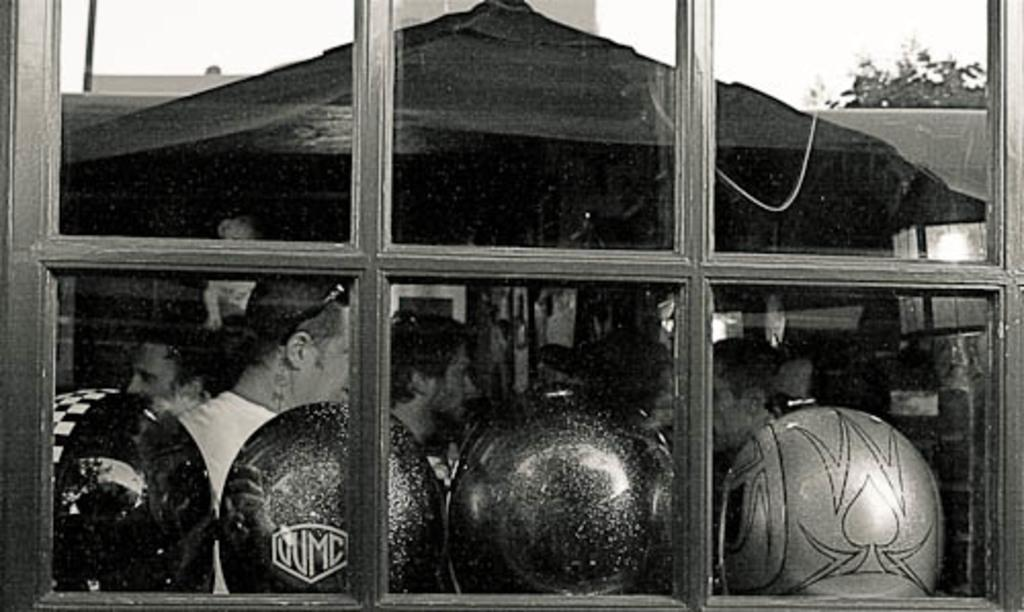What are the people in the image doing? The people in the image are standing under a tent. What protective gear can be seen in the image? There are helmets visible in the image. What type of structures are present in the image? There are buildings in the image. What natural elements can be seen in the image? Tree branches are present in the top right corner of the image. What type of furniture is present in the image? There is no furniture present in the image. What emotion are the people in the image experiencing? The image does not provide any information about the emotions of the people in the image. 